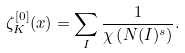Convert formula to latex. <formula><loc_0><loc_0><loc_500><loc_500>\zeta _ { K } ^ { [ 0 ] } ( x ) = \sum _ { I } \frac { 1 } { \chi \left ( N ( I ) ^ { s } \right ) } .</formula> 